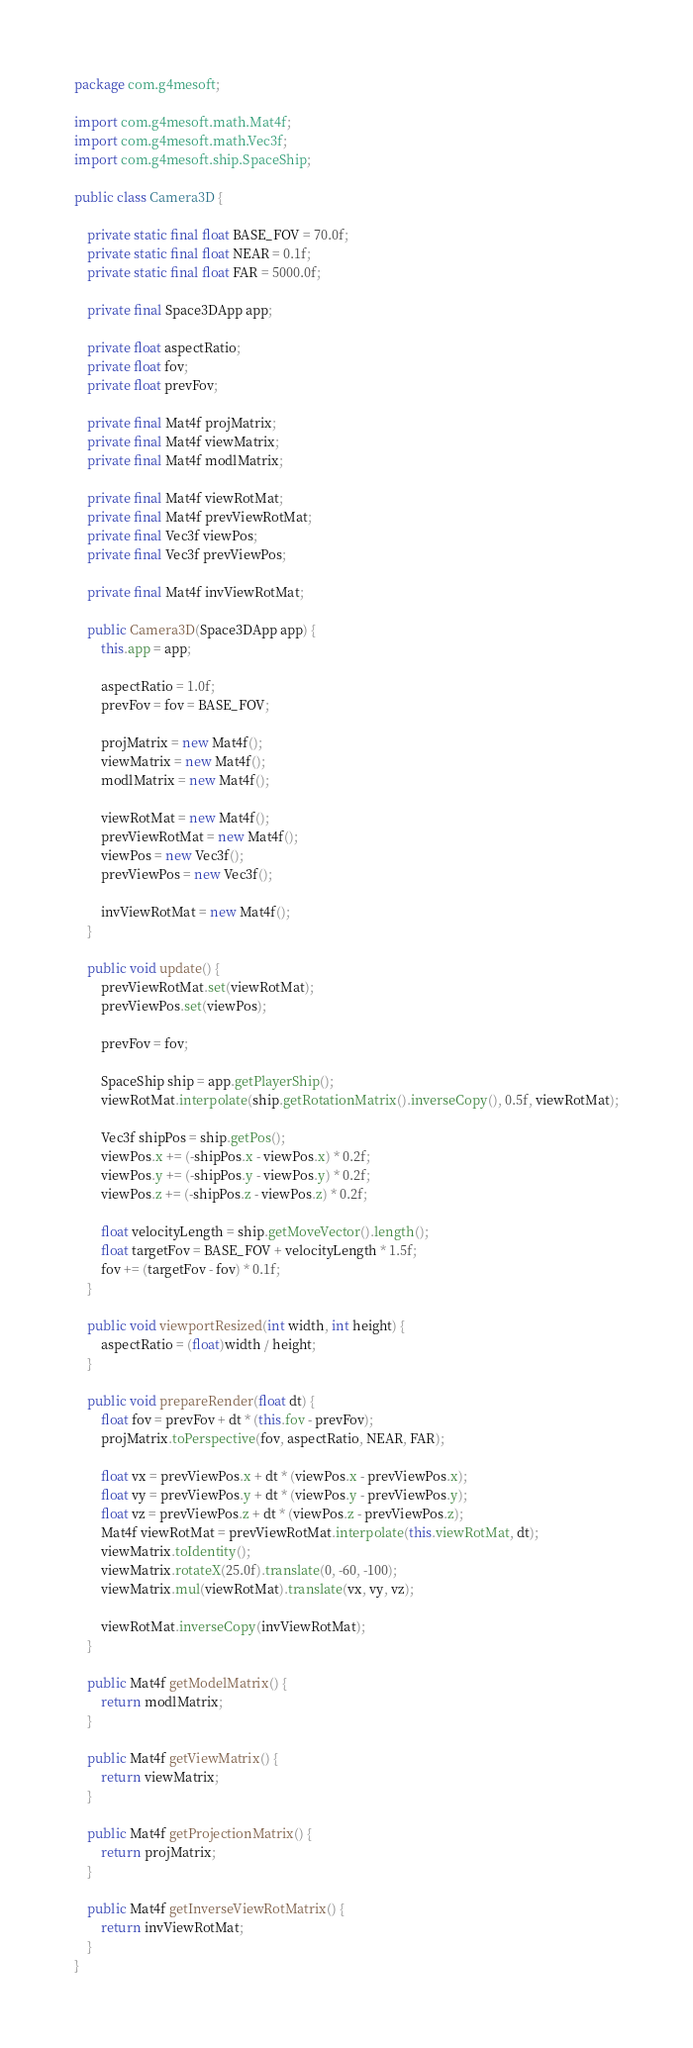<code> <loc_0><loc_0><loc_500><loc_500><_Java_>package com.g4mesoft;

import com.g4mesoft.math.Mat4f;
import com.g4mesoft.math.Vec3f;
import com.g4mesoft.ship.SpaceShip;

public class Camera3D {

	private static final float BASE_FOV = 70.0f;
	private static final float NEAR = 0.1f;
	private static final float FAR = 5000.0f;
	
	private final Space3DApp app;
	
	private float aspectRatio;
	private float fov;
	private float prevFov;
	
	private final Mat4f projMatrix;
	private final Mat4f viewMatrix;
	private final Mat4f modlMatrix;
	
	private final Mat4f viewRotMat;
	private final Mat4f prevViewRotMat;
	private final Vec3f viewPos;
	private final Vec3f prevViewPos;

	private final Mat4f invViewRotMat;
	
	public Camera3D(Space3DApp app) {
		this.app = app;
		
		aspectRatio = 1.0f;
		prevFov = fov = BASE_FOV;
		
		projMatrix = new Mat4f();
		viewMatrix = new Mat4f();
		modlMatrix = new Mat4f();
		
		viewRotMat = new Mat4f();
		prevViewRotMat = new Mat4f();
		viewPos = new Vec3f();
		prevViewPos = new Vec3f();
		
		invViewRotMat = new Mat4f();
	}
	
	public void update() {
		prevViewRotMat.set(viewRotMat);
		prevViewPos.set(viewPos);
		
		prevFov = fov;
		
		SpaceShip ship = app.getPlayerShip();
		viewRotMat.interpolate(ship.getRotationMatrix().inverseCopy(), 0.5f, viewRotMat);

		Vec3f shipPos = ship.getPos();
		viewPos.x += (-shipPos.x - viewPos.x) * 0.2f;
		viewPos.y += (-shipPos.y - viewPos.y) * 0.2f;
		viewPos.z += (-shipPos.z - viewPos.z) * 0.2f;
		
		float velocityLength = ship.getMoveVector().length();
		float targetFov = BASE_FOV + velocityLength * 1.5f;
		fov += (targetFov - fov) * 0.1f;
	}
	
	public void viewportResized(int width, int height) {
		aspectRatio = (float)width / height;
	}
	
	public void prepareRender(float dt) {
		float fov = prevFov + dt * (this.fov - prevFov);
		projMatrix.toPerspective(fov, aspectRatio, NEAR, FAR);
		
		float vx = prevViewPos.x + dt * (viewPos.x - prevViewPos.x);
		float vy = prevViewPos.y + dt * (viewPos.y - prevViewPos.y);
		float vz = prevViewPos.z + dt * (viewPos.z - prevViewPos.z);
		Mat4f viewRotMat = prevViewRotMat.interpolate(this.viewRotMat, dt);
		viewMatrix.toIdentity();
		viewMatrix.rotateX(25.0f).translate(0, -60, -100);
		viewMatrix.mul(viewRotMat).translate(vx, vy, vz);
		
		viewRotMat.inverseCopy(invViewRotMat);
	}
	
	public Mat4f getModelMatrix() {
		return modlMatrix;
	}

	public Mat4f getViewMatrix() {
		return viewMatrix;
	}

	public Mat4f getProjectionMatrix() {
		return projMatrix;
	}
	
	public Mat4f getInverseViewRotMatrix() {
		return invViewRotMat;
	}
}
</code> 